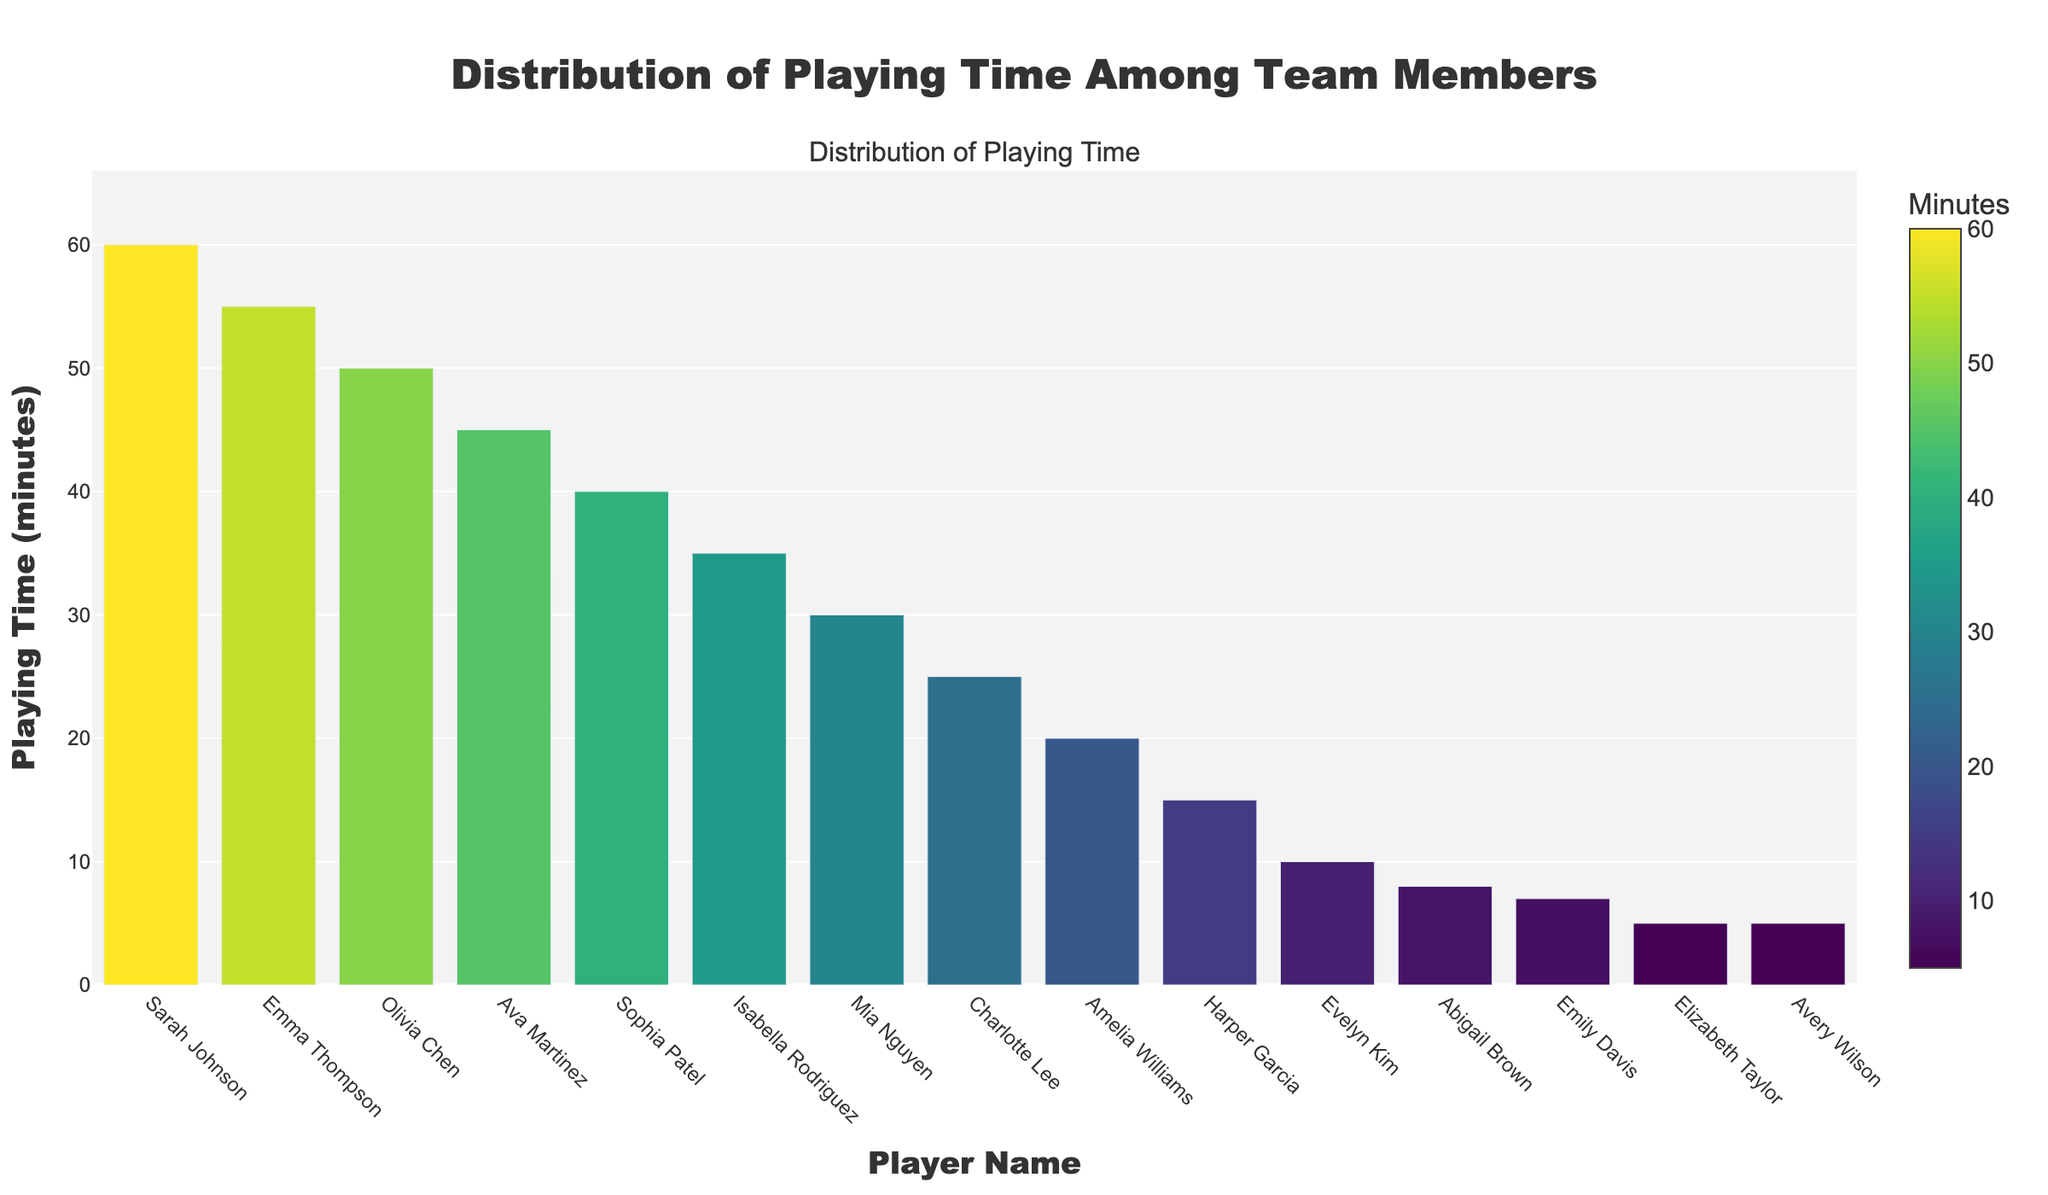What is the total playing time of the top three players? Sum the playing times of Sarah Johnson (60 minutes), Emma Thompson (55 minutes), and Olivia Chen (50 minutes). 60 + 55 + 50 = 165 minutes
Answer: 165 minutes Which player has the shortest playing time? Find the player with the shortest bar on the y-axis. Avery Wilson and Elizabeth Taylor both have the shortest bars, indicating 5 minutes each.
Answer: Avery Wilson, Elizabeth Taylor What is the average playing time for all team members? Sum all the playing times and divide by the number of players (15). Total playing time = 60 + 55 + 50 + 45 + 40 + 35 + 30 + 25 + 20 + 15 + 10 + 8 + 7 + 5 + 5 = 410 minutes. Average = 410 / 15 = 27.33 minutes
Answer: 27.33 minutes Who played 5 minutes in the match? Identify the players with bars marking 5 minutes of playing time. Avery Wilson and Elizabeth Taylor both played 5 minutes.
Answer: Avery Wilson, Elizabeth Taylor What is the difference in playing time between the player with the most playing time and the player with the least playing time? Subtract the lowest playing time from the highest playing time. 60 minutes (Sarah Johnson) - 5 minutes (Avery Wilson, Elizabeth Taylor) = 55 minutes
Answer: 55 minutes How much more did Sarah Johnson play compared to Isabella Rodriguez? Subtract Isabella Rodriguez's playing time from Sarah Johnson's playing time. 60 minutes (Sarah Johnson) - 35 minutes (Isabella Rodriguez) = 25 minutes
Answer: 25 minutes Who are the players with exactly 10 or fewer minutes of playing time? Identify the players with bars marking 10 or fewer minutes. Evelyn Kim (10 minutes), Abigail Brown (8 minutes), Emily Davis (7 minutes), Elizabeth Taylor (5 minutes), and Avery Wilson (5 minutes).
Answer: Evelyn Kim, Abigail Brown, Emily Davis, Elizabeth Taylor, Avery Wilson Which player has the median playing time, and what is it? List the playing times in ascending order and find the median. 5, 5, 7, 8, 10, 15, 20, 25, 30, 35, 40, 45, 50, 55, 60. The 8th value (middle value) is 25. The median player is Charlotte Lee.
Answer: Charlotte Lee, 25 minutes Which two players have playing times closest to each other? Identify players with minimal differences in their playing times. Mia Nguyen (30 minutes) and Charlotte Lee (25 minutes) have a difference of 5 minutes, which is the smallest among all close pairs.
Answer: Mia Nguyen and Charlotte Lee What is the total playing time for the players with over 40 minutes of playing time? Sum the playing times of Sarah Johnson (60 minutes), Emma Thompson (55 minutes), Olivia Chen (50 minutes), and Ava Martinez (45 minutes). 60 + 55 + 50 + 45 = 210 minutes
Answer: 210 minutes 